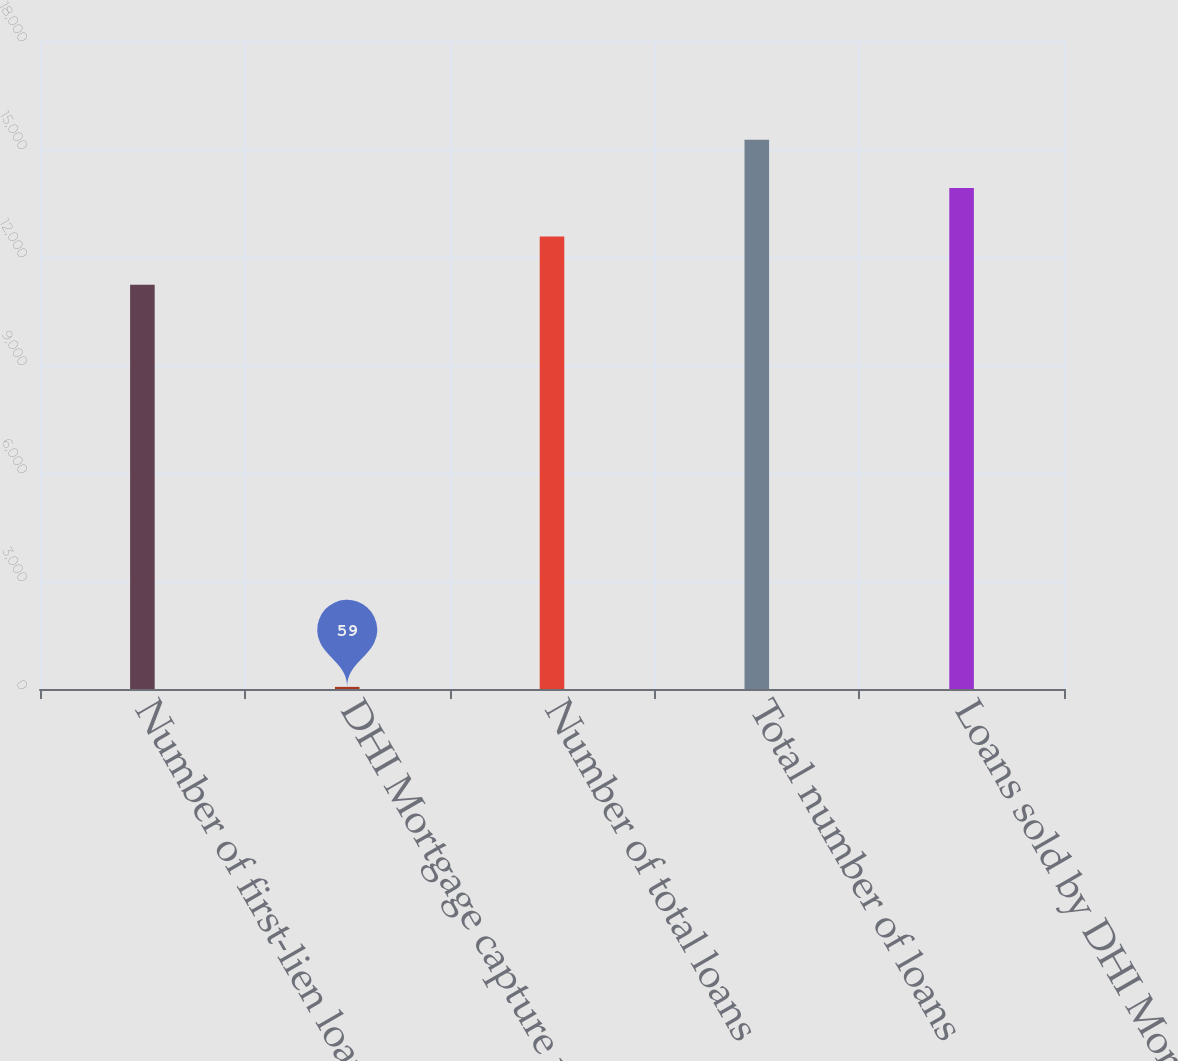Convert chart. <chart><loc_0><loc_0><loc_500><loc_500><bar_chart><fcel>Number of first-lien loans<fcel>DHI Mortgage capture rate<fcel>Number of total loans<fcel>Total number of loans<fcel>Loans sold by DHI Mortgage to<nl><fcel>11228<fcel>59<fcel>12572<fcel>15260<fcel>13916<nl></chart> 